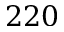<formula> <loc_0><loc_0><loc_500><loc_500>2 2 0</formula> 